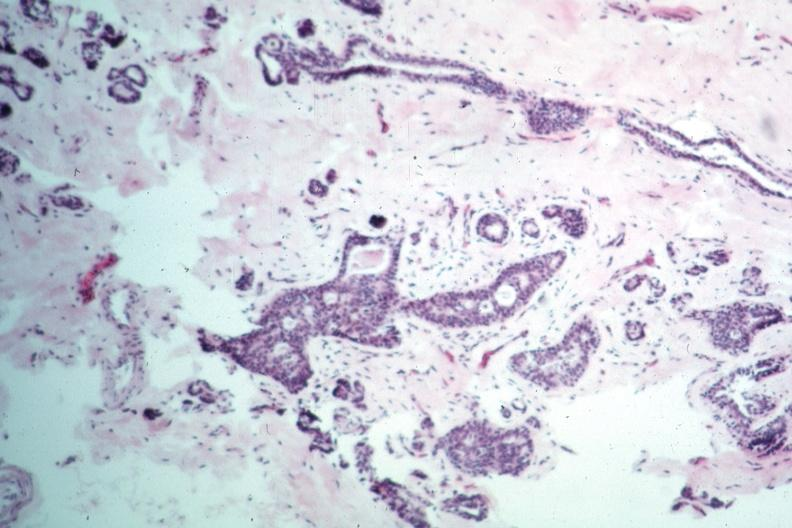what is present?
Answer the question using a single word or phrase. Intraductal papillomatosis 